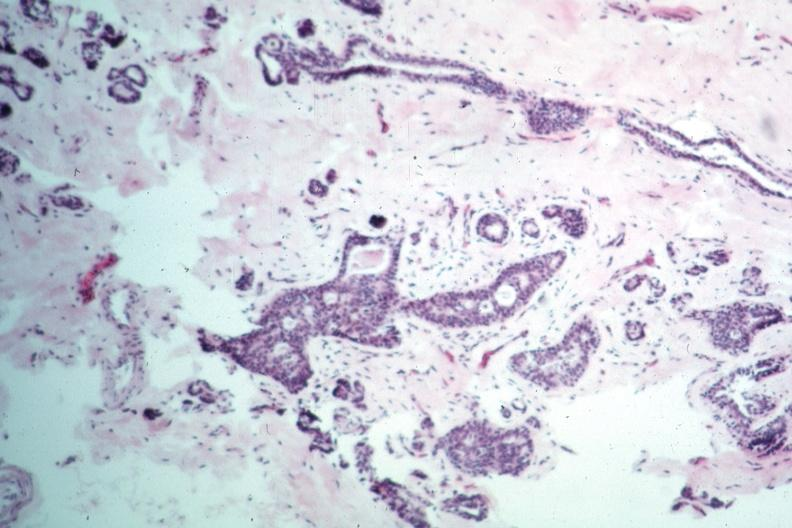what is present?
Answer the question using a single word or phrase. Intraductal papillomatosis 